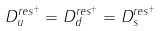<formula> <loc_0><loc_0><loc_500><loc_500>D _ { u } ^ { r e s ^ { + } } = D _ { d } ^ { r e s ^ { + } } = D _ { s } ^ { r e s ^ { + } }</formula> 